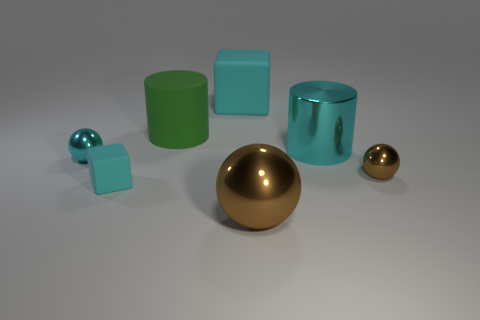What shape is the large cyan thing that is made of the same material as the small brown ball? cylinder 